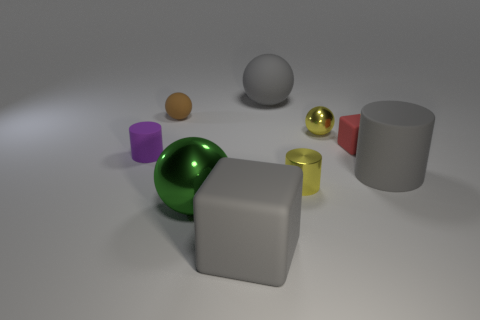How many other objects have the same shape as the small brown thing?
Make the answer very short. 3. What number of other objects are there of the same color as the big shiny ball?
Provide a succinct answer. 0. There is a yellow thing that is behind the purple object; what is its shape?
Your response must be concise. Sphere. Does the gray block have the same material as the small purple cylinder?
Your response must be concise. Yes. Is there any other thing that has the same size as the brown rubber thing?
Offer a very short reply. Yes. There is a green ball; what number of purple cylinders are to the right of it?
Provide a succinct answer. 0. What shape is the big matte object that is right of the large thing behind the purple rubber object?
Provide a short and direct response. Cylinder. Is there anything else that has the same shape as the red thing?
Offer a very short reply. Yes. Is the number of tiny balls that are left of the small metallic sphere greater than the number of large cyan spheres?
Your answer should be very brief. Yes. How many big gray things are behind the big matte cylinder that is to the right of the yellow metallic ball?
Your answer should be compact. 1. 